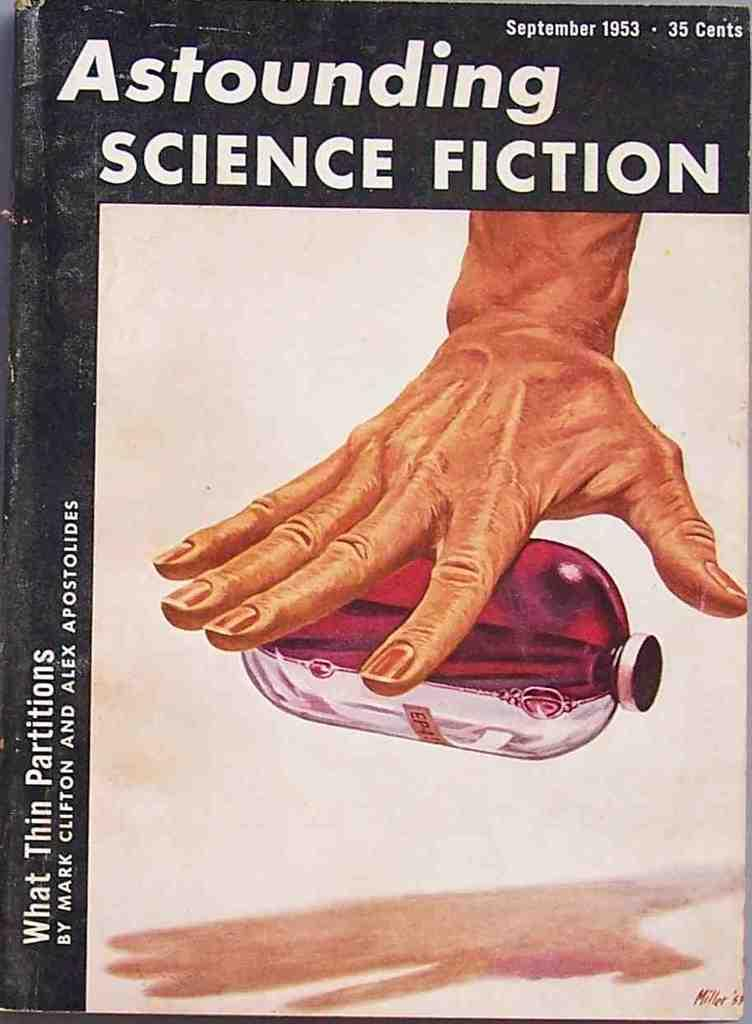<image>
Summarize the visual content of the image. The cover of a book titled Astounding Science Fiction is shown. 